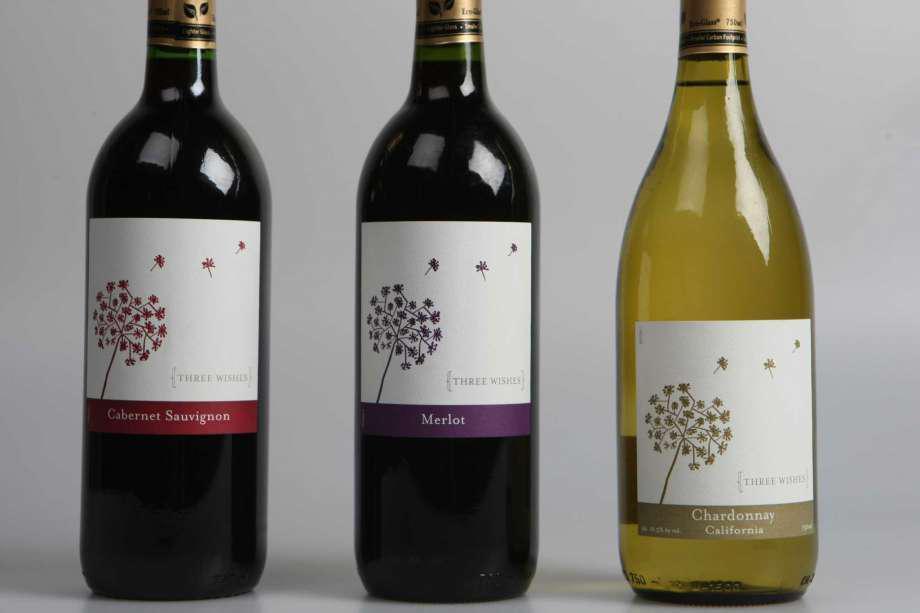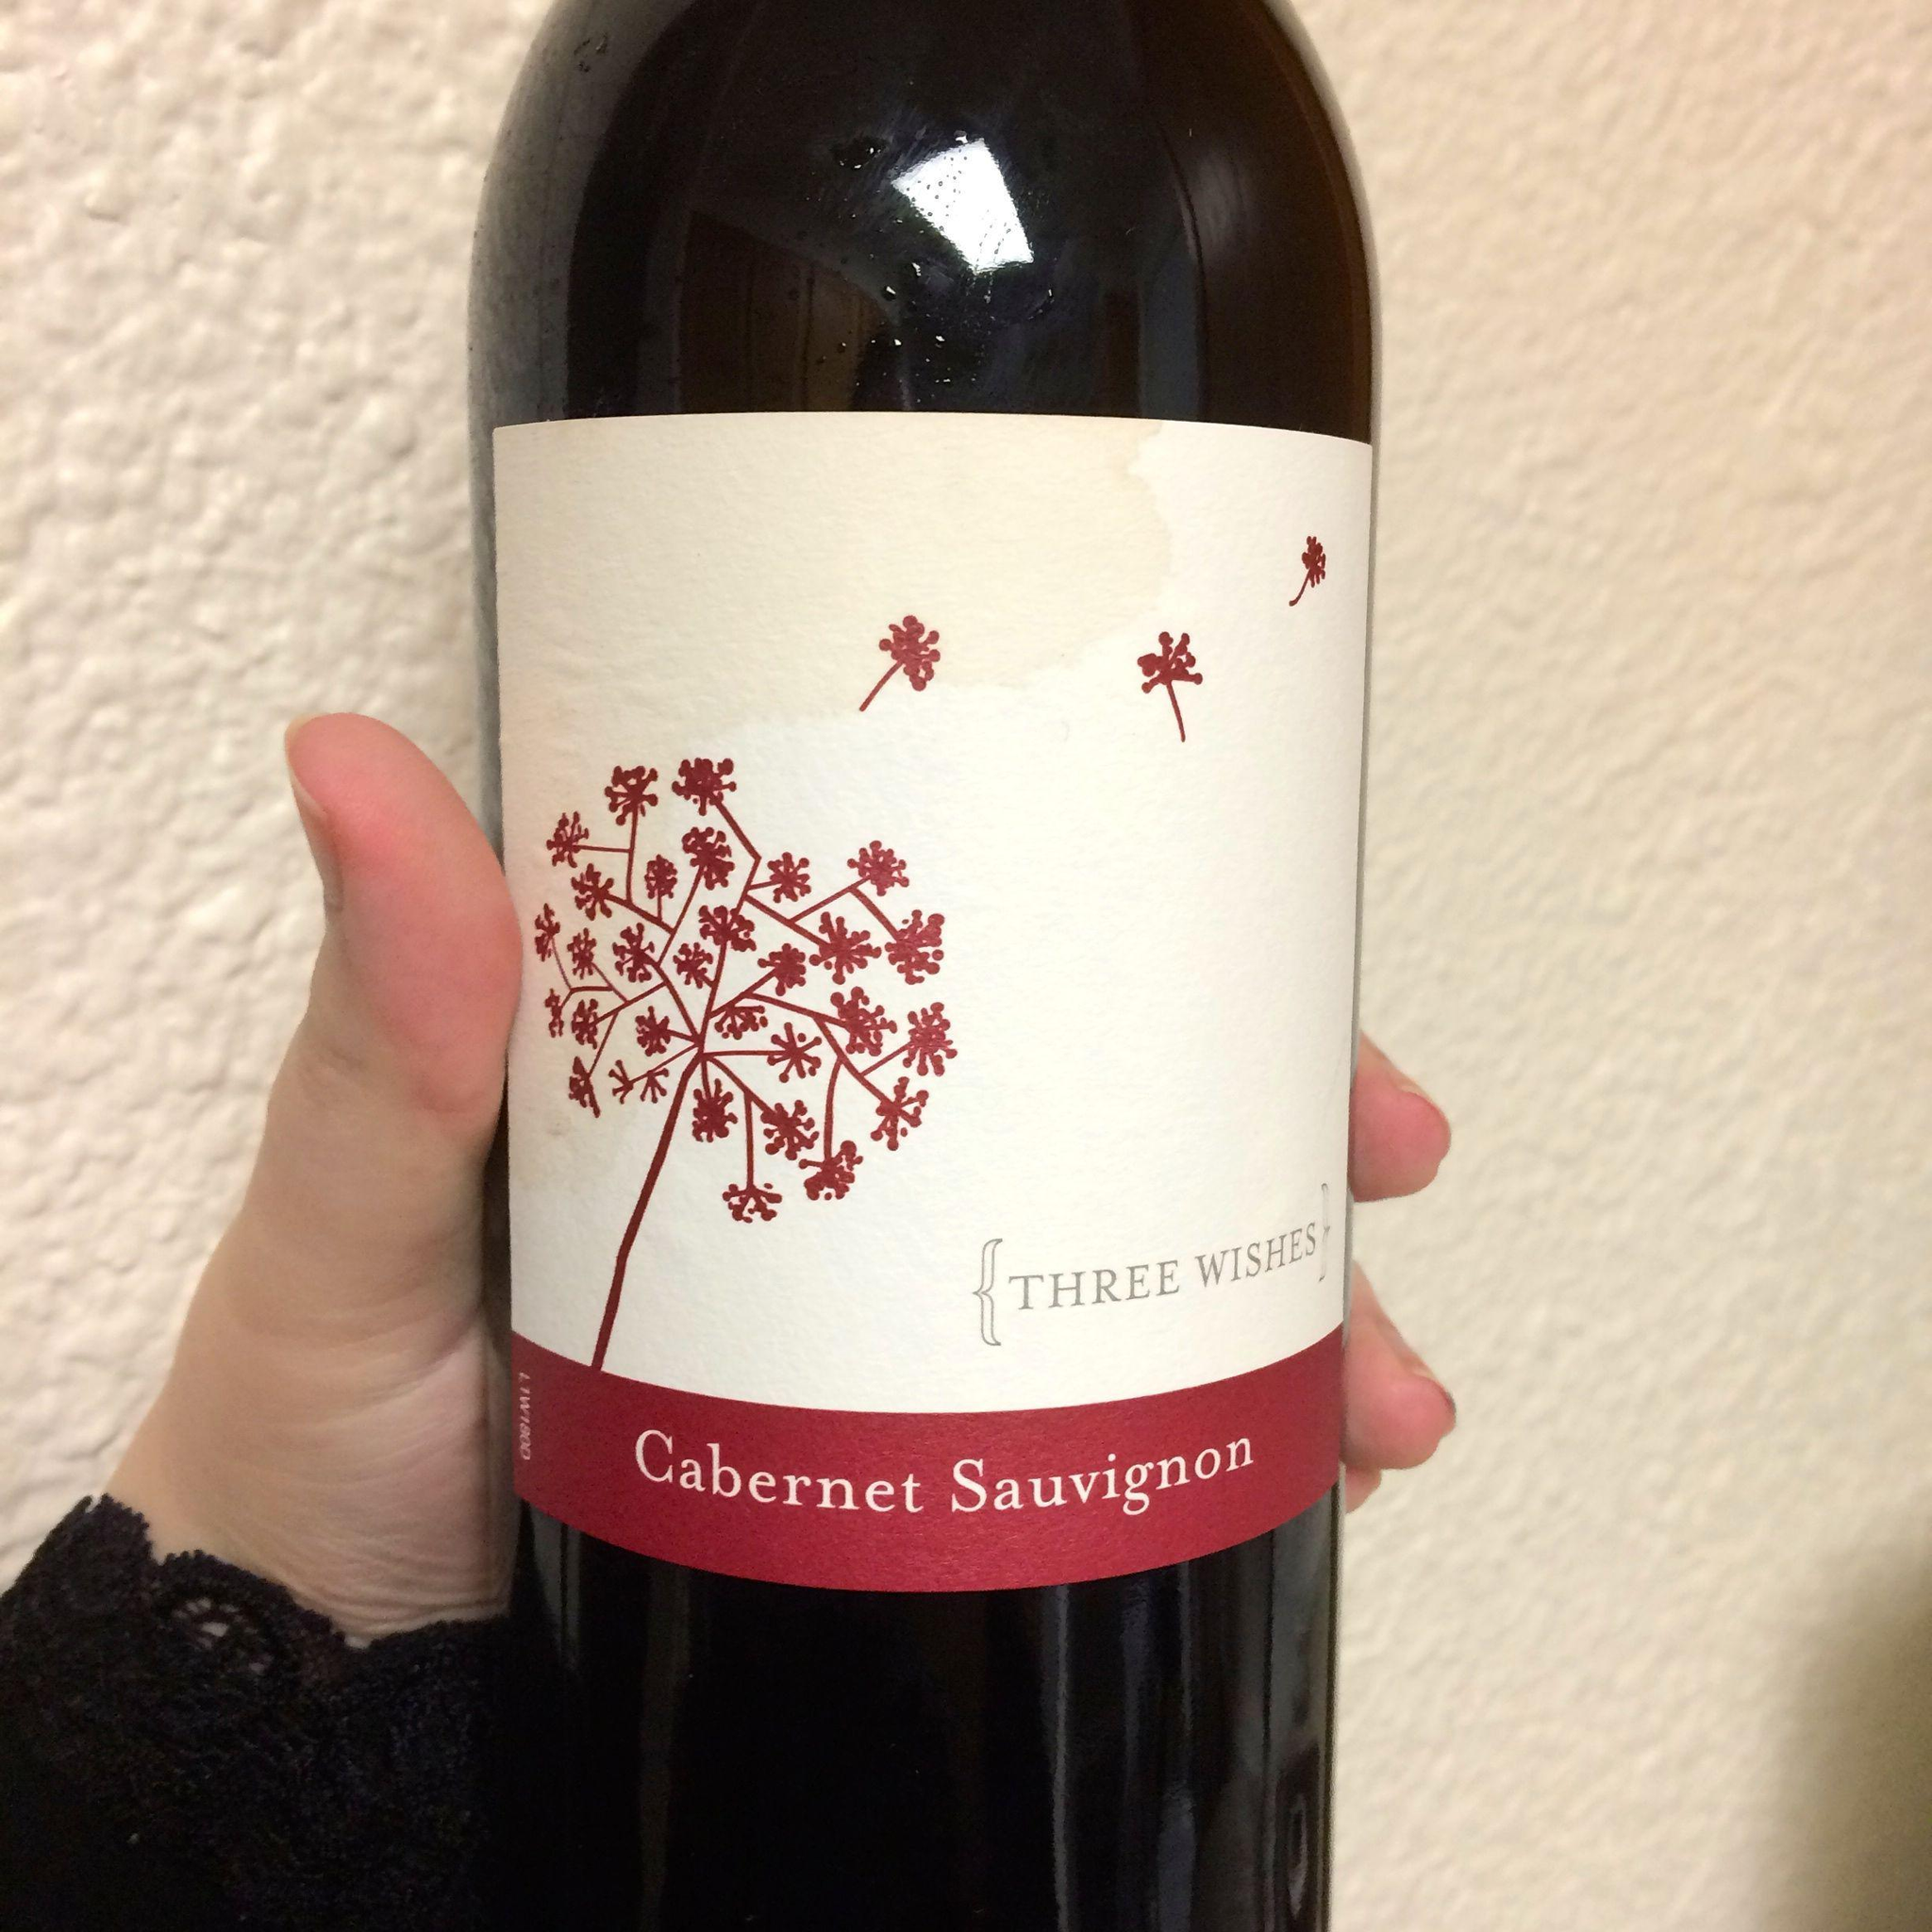The first image is the image on the left, the second image is the image on the right. Assess this claim about the two images: "There are exactly three bottles of wine featured in one of the images.". Correct or not? Answer yes or no. Yes. 